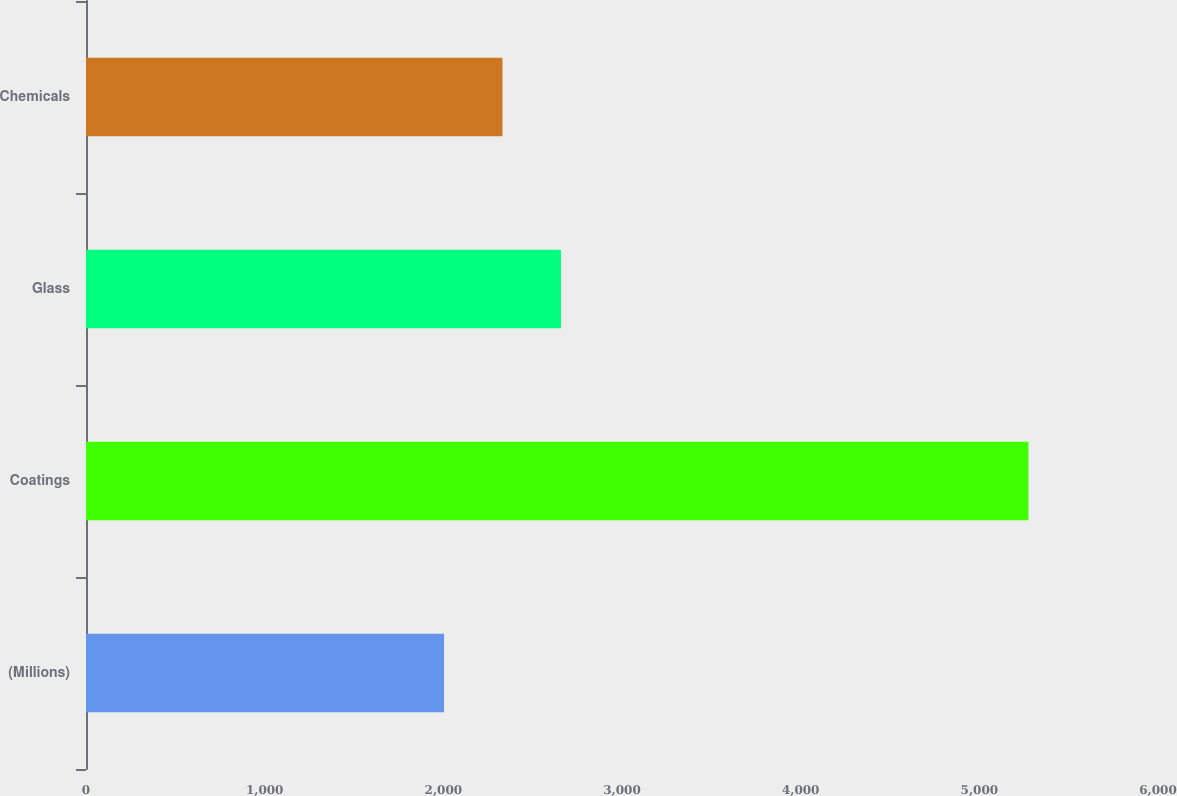<chart> <loc_0><loc_0><loc_500><loc_500><bar_chart><fcel>(Millions)<fcel>Coatings<fcel>Glass<fcel>Chemicals<nl><fcel>2004<fcel>5275<fcel>2658.2<fcel>2331.1<nl></chart> 